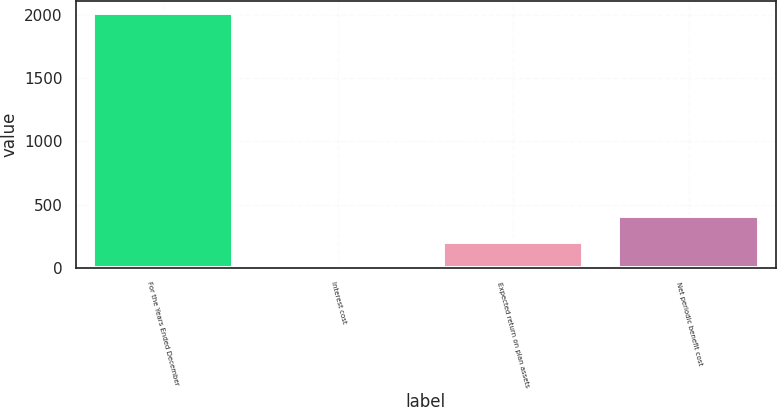Convert chart to OTSL. <chart><loc_0><loc_0><loc_500><loc_500><bar_chart><fcel>For the Years Ended December<fcel>Interest cost<fcel>Expected return on plan assets<fcel>Net periodic benefit cost<nl><fcel>2012<fcel>6.1<fcel>206.69<fcel>407.28<nl></chart> 